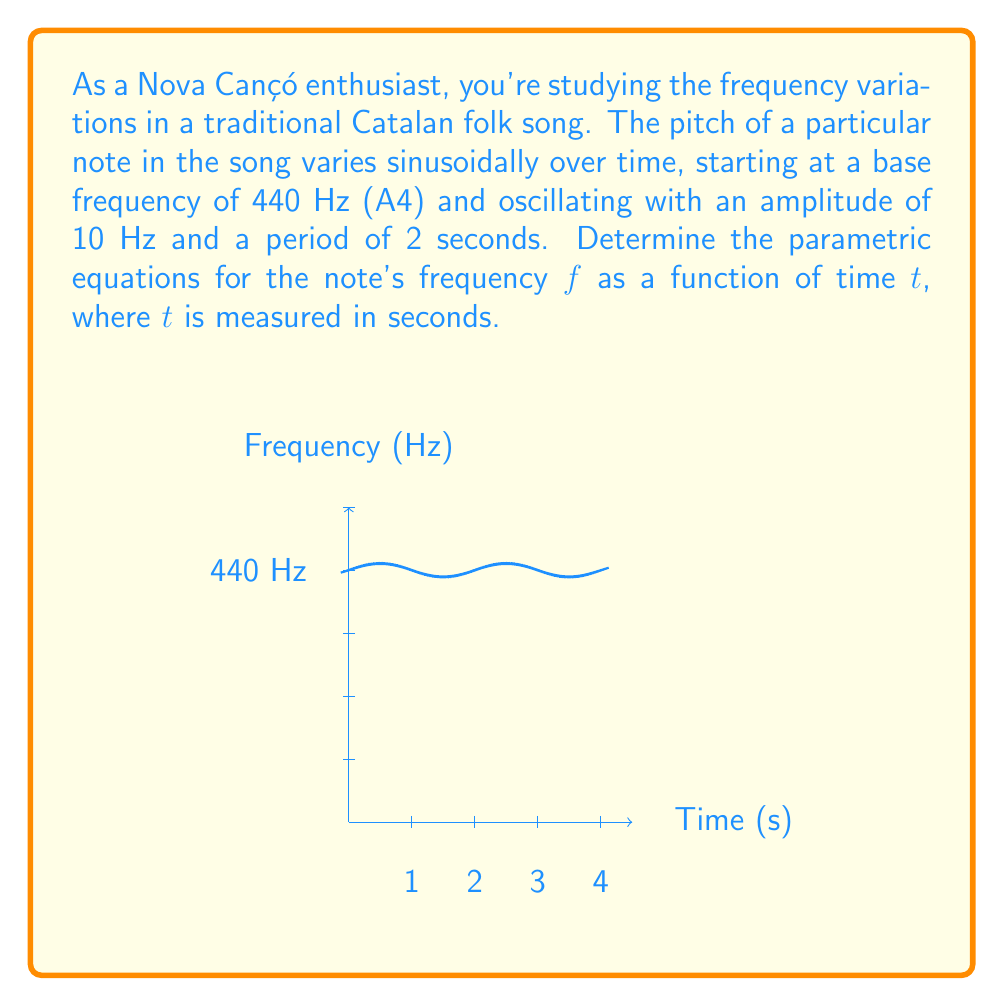Show me your answer to this math problem. To determine the parametric equations, we need to express both the frequency $f$ and time $t$ as functions of a parameter. In this case, we can use time itself as the parameter.

1) The base frequency is 440 Hz, which will be the center of our oscillation.

2) The amplitude of the oscillation is 10 Hz.

3) The period is 2 seconds, which means the angular frequency $\omega$ is:

   $\omega = \frac{2\pi}{period} = \frac{2\pi}{2} = \pi$ radians/second

4) The general form of a sinusoidal function is:

   $f(t) = A \sin(\omega t + \phi) + C$

   Where $A$ is the amplitude, $\omega$ is the angular frequency, $\phi$ is the phase shift, and $C$ is the vertical shift (in this case, our base frequency).

5) Plugging in our values:

   $f(t) = 10 \sin(\pi t) + 440$

6) For parametric equations, we express both $f$ and $t$ in terms of a parameter. Since we're using time as our parameter, we can simply write:

   $t = t$
   $f = 10 \sin(\pi t) + 440$

These are our parametric equations.
Answer: $t = t$
$f = 10 \sin(\pi t) + 440$ 